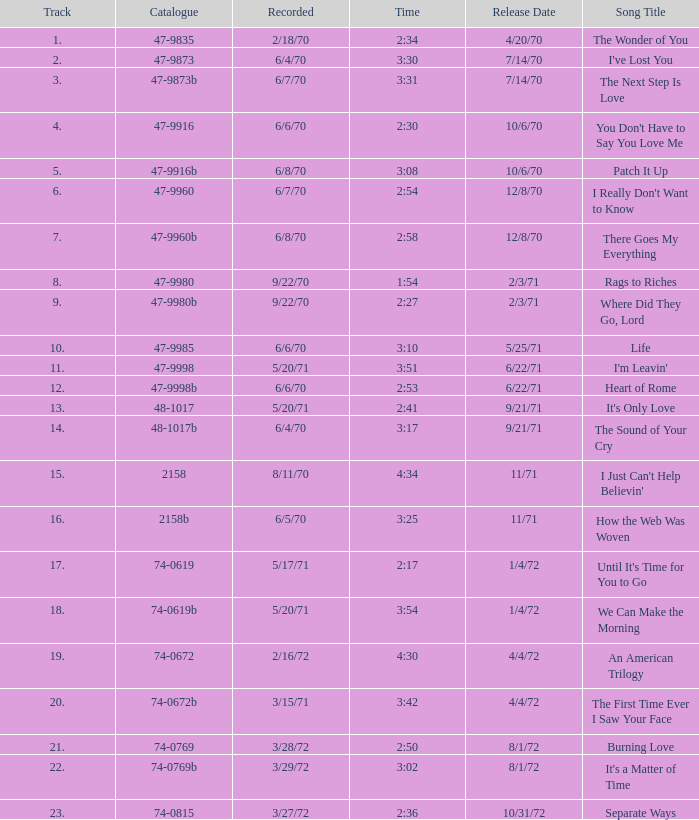Can you parse all the data within this table? {'header': ['Track', 'Catalogue', 'Recorded', 'Time', 'Release Date', 'Song Title'], 'rows': [['1.', '47-9835', '2/18/70', '2:34', '4/20/70', 'The Wonder of You'], ['2.', '47-9873', '6/4/70', '3:30', '7/14/70', "I've Lost You"], ['3.', '47-9873b', '6/7/70', '3:31', '7/14/70', 'The Next Step Is Love'], ['4.', '47-9916', '6/6/70', '2:30', '10/6/70', "You Don't Have to Say You Love Me"], ['5.', '47-9916b', '6/8/70', '3:08', '10/6/70', 'Patch It Up'], ['6.', '47-9960', '6/7/70', '2:54', '12/8/70', "I Really Don't Want to Know"], ['7.', '47-9960b', '6/8/70', '2:58', '12/8/70', 'There Goes My Everything'], ['8.', '47-9980', '9/22/70', '1:54', '2/3/71', 'Rags to Riches'], ['9.', '47-9980b', '9/22/70', '2:27', '2/3/71', 'Where Did They Go, Lord'], ['10.', '47-9985', '6/6/70', '3:10', '5/25/71', 'Life'], ['11.', '47-9998', '5/20/71', '3:51', '6/22/71', "I'm Leavin'"], ['12.', '47-9998b', '6/6/70', '2:53', '6/22/71', 'Heart of Rome'], ['13.', '48-1017', '5/20/71', '2:41', '9/21/71', "It's Only Love"], ['14.', '48-1017b', '6/4/70', '3:17', '9/21/71', 'The Sound of Your Cry'], ['15.', '2158', '8/11/70', '4:34', '11/71', "I Just Can't Help Believin'"], ['16.', '2158b', '6/5/70', '3:25', '11/71', 'How the Web Was Woven'], ['17.', '74-0619', '5/17/71', '2:17', '1/4/72', "Until It's Time for You to Go"], ['18.', '74-0619b', '5/20/71', '3:54', '1/4/72', 'We Can Make the Morning'], ['19.', '74-0672', '2/16/72', '4:30', '4/4/72', 'An American Trilogy'], ['20.', '74-0672b', '3/15/71', '3:42', '4/4/72', 'The First Time Ever I Saw Your Face'], ['21.', '74-0769', '3/28/72', '2:50', '8/1/72', 'Burning Love'], ['22.', '74-0769b', '3/29/72', '3:02', '8/1/72', "It's a Matter of Time"], ['23.', '74-0815', '3/27/72', '2:36', '10/31/72', 'Separate Ways']]} What is Heart of Rome's catalogue number? 47-9998b. 